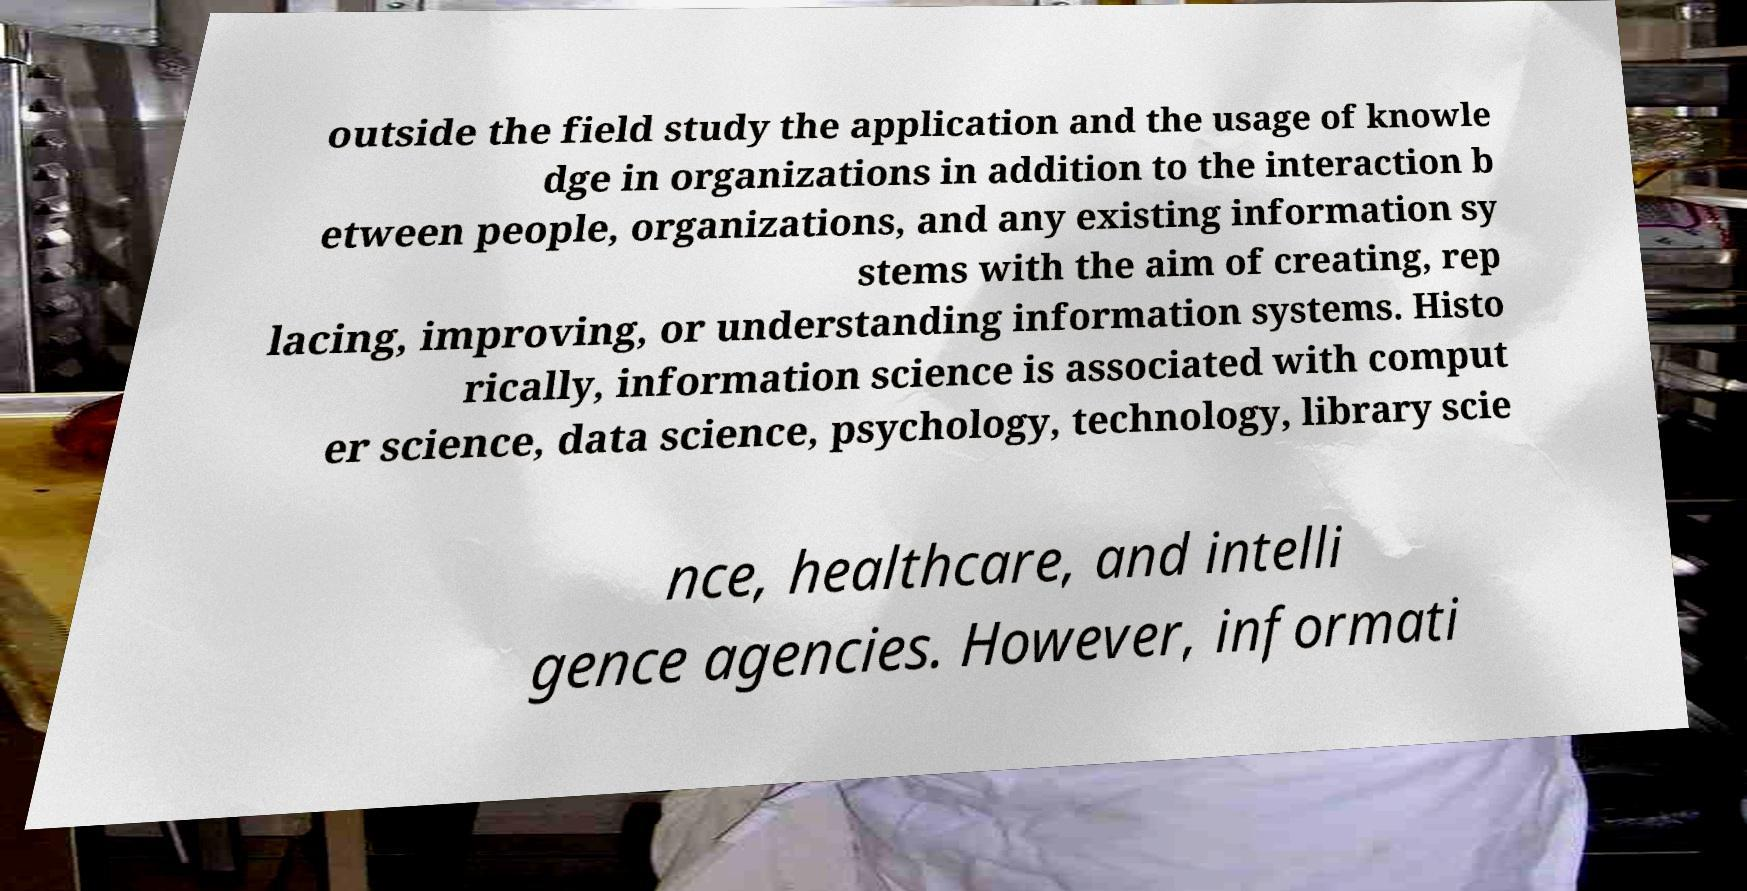Could you extract and type out the text from this image? outside the field study the application and the usage of knowle dge in organizations in addition to the interaction b etween people, organizations, and any existing information sy stems with the aim of creating, rep lacing, improving, or understanding information systems. Histo rically, information science is associated with comput er science, data science, psychology, technology, library scie nce, healthcare, and intelli gence agencies. However, informati 